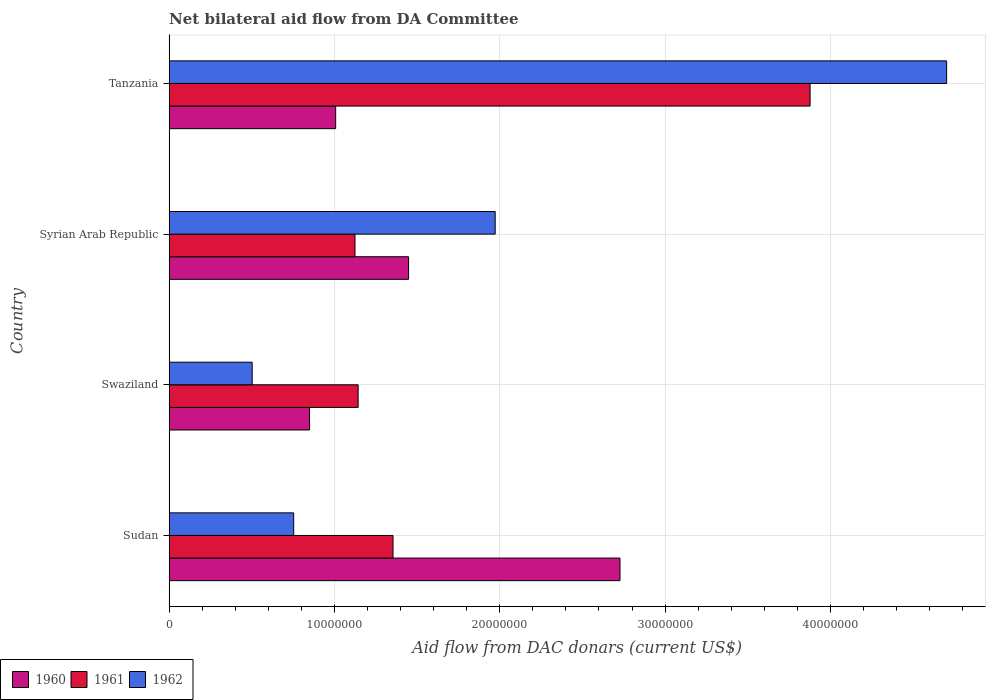Are the number of bars per tick equal to the number of legend labels?
Your answer should be very brief. Yes. How many bars are there on the 1st tick from the bottom?
Keep it short and to the point. 3. What is the label of the 4th group of bars from the top?
Give a very brief answer. Sudan. What is the aid flow in in 1960 in Swaziland?
Offer a very short reply. 8.49e+06. Across all countries, what is the maximum aid flow in in 1960?
Ensure brevity in your answer.  2.73e+07. Across all countries, what is the minimum aid flow in in 1960?
Your answer should be compact. 8.49e+06. In which country was the aid flow in in 1962 maximum?
Offer a terse response. Tanzania. In which country was the aid flow in in 1960 minimum?
Offer a terse response. Swaziland. What is the total aid flow in in 1962 in the graph?
Offer a terse response. 7.93e+07. What is the difference between the aid flow in in 1962 in Swaziland and that in Syrian Arab Republic?
Provide a succinct answer. -1.47e+07. What is the difference between the aid flow in in 1961 in Sudan and the aid flow in in 1962 in Swaziland?
Keep it short and to the point. 8.52e+06. What is the average aid flow in in 1960 per country?
Give a very brief answer. 1.51e+07. What is the difference between the aid flow in in 1961 and aid flow in in 1960 in Swaziland?
Keep it short and to the point. 2.94e+06. What is the ratio of the aid flow in in 1961 in Swaziland to that in Tanzania?
Ensure brevity in your answer.  0.29. What is the difference between the highest and the second highest aid flow in in 1962?
Offer a very short reply. 2.73e+07. What is the difference between the highest and the lowest aid flow in in 1960?
Your answer should be very brief. 1.88e+07. How many bars are there?
Make the answer very short. 12. Are all the bars in the graph horizontal?
Provide a short and direct response. Yes. Are the values on the major ticks of X-axis written in scientific E-notation?
Make the answer very short. No. Does the graph contain any zero values?
Your answer should be compact. No. How many legend labels are there?
Keep it short and to the point. 3. What is the title of the graph?
Give a very brief answer. Net bilateral aid flow from DA Committee. Does "1992" appear as one of the legend labels in the graph?
Your answer should be compact. No. What is the label or title of the X-axis?
Keep it short and to the point. Aid flow from DAC donars (current US$). What is the Aid flow from DAC donars (current US$) of 1960 in Sudan?
Make the answer very short. 2.73e+07. What is the Aid flow from DAC donars (current US$) of 1961 in Sudan?
Offer a terse response. 1.35e+07. What is the Aid flow from DAC donars (current US$) in 1962 in Sudan?
Ensure brevity in your answer.  7.53e+06. What is the Aid flow from DAC donars (current US$) of 1960 in Swaziland?
Provide a succinct answer. 8.49e+06. What is the Aid flow from DAC donars (current US$) of 1961 in Swaziland?
Provide a succinct answer. 1.14e+07. What is the Aid flow from DAC donars (current US$) in 1962 in Swaziland?
Keep it short and to the point. 5.02e+06. What is the Aid flow from DAC donars (current US$) in 1960 in Syrian Arab Republic?
Provide a short and direct response. 1.45e+07. What is the Aid flow from DAC donars (current US$) in 1961 in Syrian Arab Republic?
Offer a very short reply. 1.12e+07. What is the Aid flow from DAC donars (current US$) in 1962 in Syrian Arab Republic?
Give a very brief answer. 1.97e+07. What is the Aid flow from DAC donars (current US$) of 1960 in Tanzania?
Offer a very short reply. 1.01e+07. What is the Aid flow from DAC donars (current US$) in 1961 in Tanzania?
Keep it short and to the point. 3.88e+07. What is the Aid flow from DAC donars (current US$) in 1962 in Tanzania?
Your response must be concise. 4.70e+07. Across all countries, what is the maximum Aid flow from DAC donars (current US$) in 1960?
Offer a terse response. 2.73e+07. Across all countries, what is the maximum Aid flow from DAC donars (current US$) of 1961?
Keep it short and to the point. 3.88e+07. Across all countries, what is the maximum Aid flow from DAC donars (current US$) in 1962?
Offer a terse response. 4.70e+07. Across all countries, what is the minimum Aid flow from DAC donars (current US$) in 1960?
Provide a succinct answer. 8.49e+06. Across all countries, what is the minimum Aid flow from DAC donars (current US$) in 1961?
Your answer should be very brief. 1.12e+07. Across all countries, what is the minimum Aid flow from DAC donars (current US$) in 1962?
Give a very brief answer. 5.02e+06. What is the total Aid flow from DAC donars (current US$) in 1960 in the graph?
Your answer should be compact. 6.03e+07. What is the total Aid flow from DAC donars (current US$) of 1961 in the graph?
Your answer should be very brief. 7.50e+07. What is the total Aid flow from DAC donars (current US$) of 1962 in the graph?
Give a very brief answer. 7.93e+07. What is the difference between the Aid flow from DAC donars (current US$) in 1960 in Sudan and that in Swaziland?
Your response must be concise. 1.88e+07. What is the difference between the Aid flow from DAC donars (current US$) of 1961 in Sudan and that in Swaziland?
Your answer should be compact. 2.11e+06. What is the difference between the Aid flow from DAC donars (current US$) in 1962 in Sudan and that in Swaziland?
Provide a short and direct response. 2.51e+06. What is the difference between the Aid flow from DAC donars (current US$) in 1960 in Sudan and that in Syrian Arab Republic?
Your answer should be very brief. 1.28e+07. What is the difference between the Aid flow from DAC donars (current US$) in 1961 in Sudan and that in Syrian Arab Republic?
Your answer should be compact. 2.30e+06. What is the difference between the Aid flow from DAC donars (current US$) in 1962 in Sudan and that in Syrian Arab Republic?
Your answer should be very brief. -1.22e+07. What is the difference between the Aid flow from DAC donars (current US$) of 1960 in Sudan and that in Tanzania?
Ensure brevity in your answer.  1.72e+07. What is the difference between the Aid flow from DAC donars (current US$) in 1961 in Sudan and that in Tanzania?
Give a very brief answer. -2.52e+07. What is the difference between the Aid flow from DAC donars (current US$) in 1962 in Sudan and that in Tanzania?
Your response must be concise. -3.95e+07. What is the difference between the Aid flow from DAC donars (current US$) of 1960 in Swaziland and that in Syrian Arab Republic?
Make the answer very short. -5.99e+06. What is the difference between the Aid flow from DAC donars (current US$) of 1961 in Swaziland and that in Syrian Arab Republic?
Keep it short and to the point. 1.90e+05. What is the difference between the Aid flow from DAC donars (current US$) of 1962 in Swaziland and that in Syrian Arab Republic?
Your answer should be compact. -1.47e+07. What is the difference between the Aid flow from DAC donars (current US$) in 1960 in Swaziland and that in Tanzania?
Keep it short and to the point. -1.58e+06. What is the difference between the Aid flow from DAC donars (current US$) of 1961 in Swaziland and that in Tanzania?
Provide a short and direct response. -2.73e+07. What is the difference between the Aid flow from DAC donars (current US$) of 1962 in Swaziland and that in Tanzania?
Your answer should be compact. -4.20e+07. What is the difference between the Aid flow from DAC donars (current US$) of 1960 in Syrian Arab Republic and that in Tanzania?
Provide a succinct answer. 4.41e+06. What is the difference between the Aid flow from DAC donars (current US$) in 1961 in Syrian Arab Republic and that in Tanzania?
Give a very brief answer. -2.75e+07. What is the difference between the Aid flow from DAC donars (current US$) of 1962 in Syrian Arab Republic and that in Tanzania?
Provide a short and direct response. -2.73e+07. What is the difference between the Aid flow from DAC donars (current US$) of 1960 in Sudan and the Aid flow from DAC donars (current US$) of 1961 in Swaziland?
Your response must be concise. 1.58e+07. What is the difference between the Aid flow from DAC donars (current US$) in 1960 in Sudan and the Aid flow from DAC donars (current US$) in 1962 in Swaziland?
Provide a short and direct response. 2.22e+07. What is the difference between the Aid flow from DAC donars (current US$) of 1961 in Sudan and the Aid flow from DAC donars (current US$) of 1962 in Swaziland?
Provide a short and direct response. 8.52e+06. What is the difference between the Aid flow from DAC donars (current US$) in 1960 in Sudan and the Aid flow from DAC donars (current US$) in 1961 in Syrian Arab Republic?
Provide a short and direct response. 1.60e+07. What is the difference between the Aid flow from DAC donars (current US$) of 1960 in Sudan and the Aid flow from DAC donars (current US$) of 1962 in Syrian Arab Republic?
Your answer should be compact. 7.55e+06. What is the difference between the Aid flow from DAC donars (current US$) of 1961 in Sudan and the Aid flow from DAC donars (current US$) of 1962 in Syrian Arab Republic?
Give a very brief answer. -6.18e+06. What is the difference between the Aid flow from DAC donars (current US$) of 1960 in Sudan and the Aid flow from DAC donars (current US$) of 1961 in Tanzania?
Your answer should be very brief. -1.15e+07. What is the difference between the Aid flow from DAC donars (current US$) in 1960 in Sudan and the Aid flow from DAC donars (current US$) in 1962 in Tanzania?
Provide a succinct answer. -1.98e+07. What is the difference between the Aid flow from DAC donars (current US$) of 1961 in Sudan and the Aid flow from DAC donars (current US$) of 1962 in Tanzania?
Keep it short and to the point. -3.35e+07. What is the difference between the Aid flow from DAC donars (current US$) of 1960 in Swaziland and the Aid flow from DAC donars (current US$) of 1961 in Syrian Arab Republic?
Provide a succinct answer. -2.75e+06. What is the difference between the Aid flow from DAC donars (current US$) of 1960 in Swaziland and the Aid flow from DAC donars (current US$) of 1962 in Syrian Arab Republic?
Provide a short and direct response. -1.12e+07. What is the difference between the Aid flow from DAC donars (current US$) of 1961 in Swaziland and the Aid flow from DAC donars (current US$) of 1962 in Syrian Arab Republic?
Offer a very short reply. -8.29e+06. What is the difference between the Aid flow from DAC donars (current US$) in 1960 in Swaziland and the Aid flow from DAC donars (current US$) in 1961 in Tanzania?
Provide a short and direct response. -3.03e+07. What is the difference between the Aid flow from DAC donars (current US$) of 1960 in Swaziland and the Aid flow from DAC donars (current US$) of 1962 in Tanzania?
Your answer should be very brief. -3.85e+07. What is the difference between the Aid flow from DAC donars (current US$) of 1961 in Swaziland and the Aid flow from DAC donars (current US$) of 1962 in Tanzania?
Offer a terse response. -3.56e+07. What is the difference between the Aid flow from DAC donars (current US$) of 1960 in Syrian Arab Republic and the Aid flow from DAC donars (current US$) of 1961 in Tanzania?
Keep it short and to the point. -2.43e+07. What is the difference between the Aid flow from DAC donars (current US$) of 1960 in Syrian Arab Republic and the Aid flow from DAC donars (current US$) of 1962 in Tanzania?
Make the answer very short. -3.26e+07. What is the difference between the Aid flow from DAC donars (current US$) of 1961 in Syrian Arab Republic and the Aid flow from DAC donars (current US$) of 1962 in Tanzania?
Keep it short and to the point. -3.58e+07. What is the average Aid flow from DAC donars (current US$) in 1960 per country?
Your answer should be compact. 1.51e+07. What is the average Aid flow from DAC donars (current US$) in 1961 per country?
Keep it short and to the point. 1.87e+07. What is the average Aid flow from DAC donars (current US$) in 1962 per country?
Your answer should be very brief. 1.98e+07. What is the difference between the Aid flow from DAC donars (current US$) in 1960 and Aid flow from DAC donars (current US$) in 1961 in Sudan?
Offer a very short reply. 1.37e+07. What is the difference between the Aid flow from DAC donars (current US$) in 1960 and Aid flow from DAC donars (current US$) in 1962 in Sudan?
Your answer should be compact. 1.97e+07. What is the difference between the Aid flow from DAC donars (current US$) in 1961 and Aid flow from DAC donars (current US$) in 1962 in Sudan?
Provide a succinct answer. 6.01e+06. What is the difference between the Aid flow from DAC donars (current US$) in 1960 and Aid flow from DAC donars (current US$) in 1961 in Swaziland?
Offer a very short reply. -2.94e+06. What is the difference between the Aid flow from DAC donars (current US$) in 1960 and Aid flow from DAC donars (current US$) in 1962 in Swaziland?
Offer a very short reply. 3.47e+06. What is the difference between the Aid flow from DAC donars (current US$) of 1961 and Aid flow from DAC donars (current US$) of 1962 in Swaziland?
Make the answer very short. 6.41e+06. What is the difference between the Aid flow from DAC donars (current US$) in 1960 and Aid flow from DAC donars (current US$) in 1961 in Syrian Arab Republic?
Make the answer very short. 3.24e+06. What is the difference between the Aid flow from DAC donars (current US$) in 1960 and Aid flow from DAC donars (current US$) in 1962 in Syrian Arab Republic?
Offer a very short reply. -5.24e+06. What is the difference between the Aid flow from DAC donars (current US$) of 1961 and Aid flow from DAC donars (current US$) of 1962 in Syrian Arab Republic?
Provide a succinct answer. -8.48e+06. What is the difference between the Aid flow from DAC donars (current US$) in 1960 and Aid flow from DAC donars (current US$) in 1961 in Tanzania?
Your answer should be very brief. -2.87e+07. What is the difference between the Aid flow from DAC donars (current US$) of 1960 and Aid flow from DAC donars (current US$) of 1962 in Tanzania?
Give a very brief answer. -3.70e+07. What is the difference between the Aid flow from DAC donars (current US$) in 1961 and Aid flow from DAC donars (current US$) in 1962 in Tanzania?
Provide a succinct answer. -8.26e+06. What is the ratio of the Aid flow from DAC donars (current US$) in 1960 in Sudan to that in Swaziland?
Offer a terse response. 3.21. What is the ratio of the Aid flow from DAC donars (current US$) in 1961 in Sudan to that in Swaziland?
Provide a short and direct response. 1.18. What is the ratio of the Aid flow from DAC donars (current US$) of 1962 in Sudan to that in Swaziland?
Ensure brevity in your answer.  1.5. What is the ratio of the Aid flow from DAC donars (current US$) in 1960 in Sudan to that in Syrian Arab Republic?
Offer a very short reply. 1.88. What is the ratio of the Aid flow from DAC donars (current US$) in 1961 in Sudan to that in Syrian Arab Republic?
Your response must be concise. 1.2. What is the ratio of the Aid flow from DAC donars (current US$) in 1962 in Sudan to that in Syrian Arab Republic?
Your answer should be compact. 0.38. What is the ratio of the Aid flow from DAC donars (current US$) in 1960 in Sudan to that in Tanzania?
Your answer should be very brief. 2.71. What is the ratio of the Aid flow from DAC donars (current US$) in 1961 in Sudan to that in Tanzania?
Make the answer very short. 0.35. What is the ratio of the Aid flow from DAC donars (current US$) in 1962 in Sudan to that in Tanzania?
Give a very brief answer. 0.16. What is the ratio of the Aid flow from DAC donars (current US$) of 1960 in Swaziland to that in Syrian Arab Republic?
Your answer should be compact. 0.59. What is the ratio of the Aid flow from DAC donars (current US$) in 1961 in Swaziland to that in Syrian Arab Republic?
Offer a terse response. 1.02. What is the ratio of the Aid flow from DAC donars (current US$) of 1962 in Swaziland to that in Syrian Arab Republic?
Your response must be concise. 0.25. What is the ratio of the Aid flow from DAC donars (current US$) of 1960 in Swaziland to that in Tanzania?
Provide a succinct answer. 0.84. What is the ratio of the Aid flow from DAC donars (current US$) in 1961 in Swaziland to that in Tanzania?
Give a very brief answer. 0.29. What is the ratio of the Aid flow from DAC donars (current US$) in 1962 in Swaziland to that in Tanzania?
Ensure brevity in your answer.  0.11. What is the ratio of the Aid flow from DAC donars (current US$) of 1960 in Syrian Arab Republic to that in Tanzania?
Give a very brief answer. 1.44. What is the ratio of the Aid flow from DAC donars (current US$) in 1961 in Syrian Arab Republic to that in Tanzania?
Keep it short and to the point. 0.29. What is the ratio of the Aid flow from DAC donars (current US$) in 1962 in Syrian Arab Republic to that in Tanzania?
Your answer should be compact. 0.42. What is the difference between the highest and the second highest Aid flow from DAC donars (current US$) of 1960?
Provide a succinct answer. 1.28e+07. What is the difference between the highest and the second highest Aid flow from DAC donars (current US$) in 1961?
Offer a terse response. 2.52e+07. What is the difference between the highest and the second highest Aid flow from DAC donars (current US$) in 1962?
Offer a very short reply. 2.73e+07. What is the difference between the highest and the lowest Aid flow from DAC donars (current US$) in 1960?
Provide a short and direct response. 1.88e+07. What is the difference between the highest and the lowest Aid flow from DAC donars (current US$) of 1961?
Keep it short and to the point. 2.75e+07. What is the difference between the highest and the lowest Aid flow from DAC donars (current US$) in 1962?
Your response must be concise. 4.20e+07. 